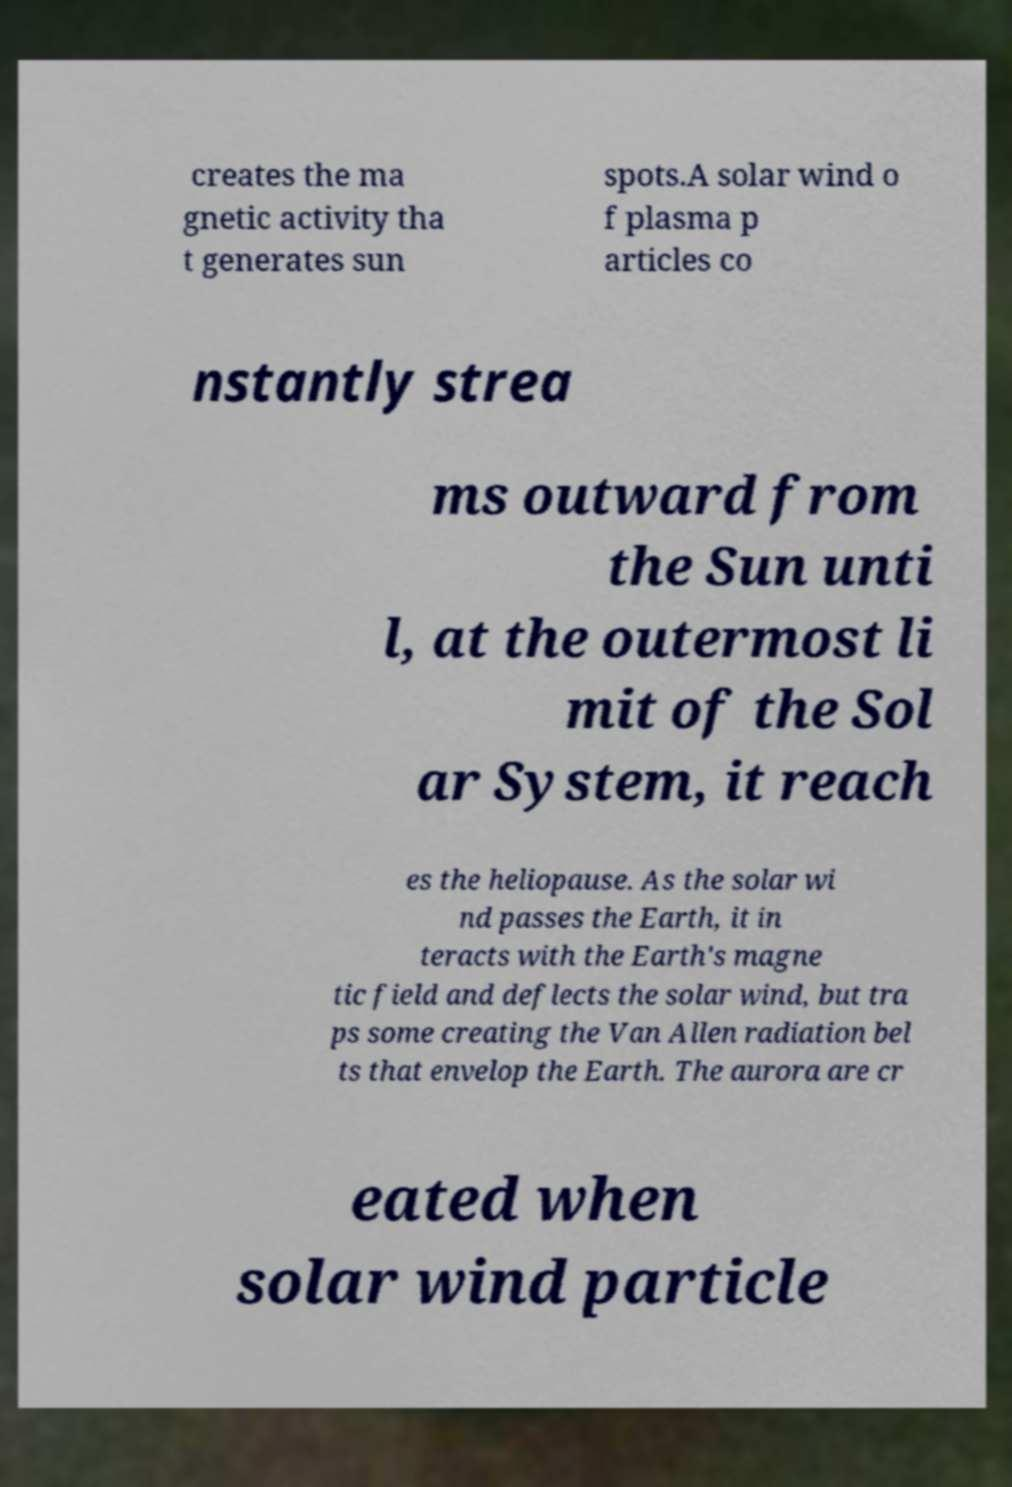Please identify and transcribe the text found in this image. creates the ma gnetic activity tha t generates sun spots.A solar wind o f plasma p articles co nstantly strea ms outward from the Sun unti l, at the outermost li mit of the Sol ar System, it reach es the heliopause. As the solar wi nd passes the Earth, it in teracts with the Earth's magne tic field and deflects the solar wind, but tra ps some creating the Van Allen radiation bel ts that envelop the Earth. The aurora are cr eated when solar wind particle 